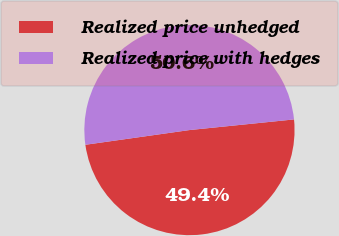Convert chart. <chart><loc_0><loc_0><loc_500><loc_500><pie_chart><fcel>Realized price unhedged<fcel>Realized price with hedges<nl><fcel>49.38%<fcel>50.62%<nl></chart> 